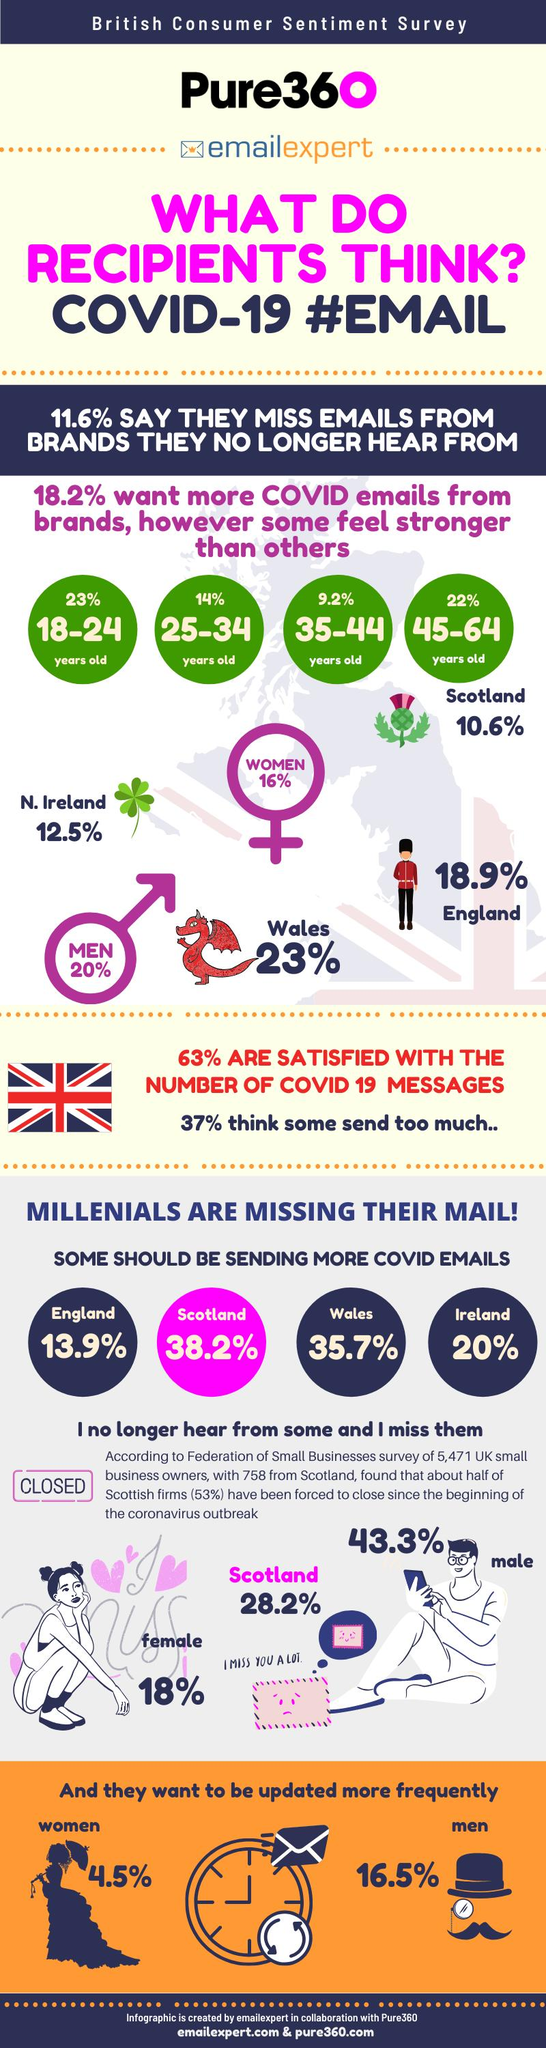Outline some significant characteristics in this image. The time displayed on the clock is nine o'clock. In the infographic, the flag of the United Kingdom or Ireland is displayed. 